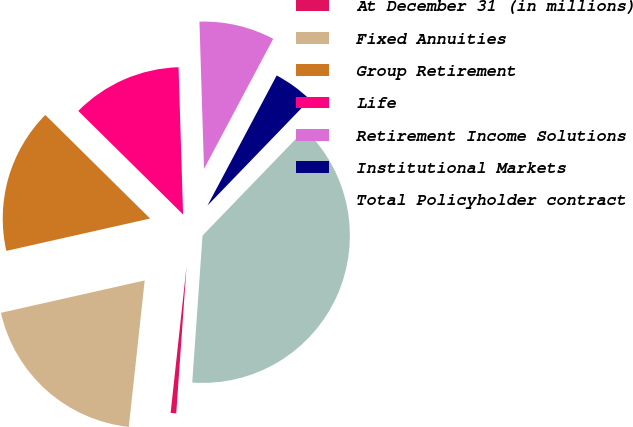Convert chart. <chart><loc_0><loc_0><loc_500><loc_500><pie_chart><fcel>At December 31 (in millions)<fcel>Fixed Annuities<fcel>Group Retirement<fcel>Life<fcel>Retirement Income Solutions<fcel>Institutional Markets<fcel>Total Policyholder contract<nl><fcel>0.61%<fcel>19.75%<fcel>15.93%<fcel>12.1%<fcel>8.27%<fcel>4.44%<fcel>38.89%<nl></chart> 